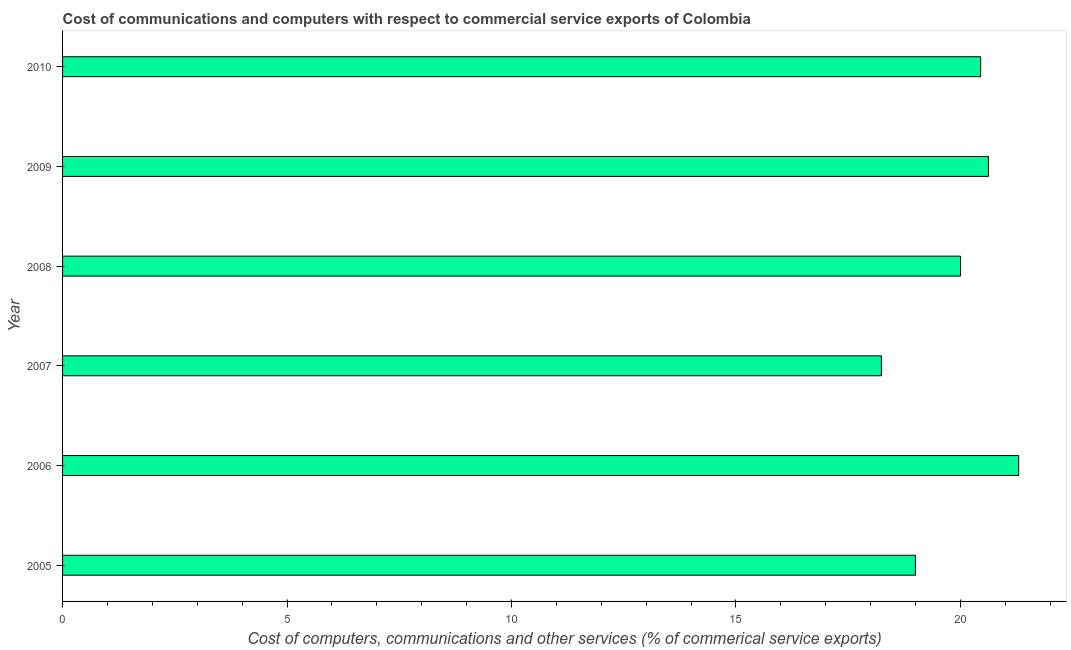What is the title of the graph?
Ensure brevity in your answer.  Cost of communications and computers with respect to commercial service exports of Colombia. What is the label or title of the X-axis?
Provide a succinct answer. Cost of computers, communications and other services (% of commerical service exports). What is the label or title of the Y-axis?
Your answer should be very brief. Year. What is the cost of communications in 2006?
Keep it short and to the point. 21.3. Across all years, what is the maximum cost of communications?
Offer a very short reply. 21.3. Across all years, what is the minimum  computer and other services?
Offer a very short reply. 18.24. In which year was the cost of communications maximum?
Your answer should be very brief. 2006. In which year was the  computer and other services minimum?
Your answer should be very brief. 2007. What is the sum of the  computer and other services?
Your response must be concise. 119.62. What is the difference between the cost of communications in 2005 and 2009?
Your answer should be very brief. -1.63. What is the average  computer and other services per year?
Ensure brevity in your answer.  19.94. What is the median cost of communications?
Ensure brevity in your answer.  20.23. What is the ratio of the cost of communications in 2007 to that in 2008?
Your answer should be very brief. 0.91. Is the  computer and other services in 2006 less than that in 2010?
Keep it short and to the point. No. What is the difference between the highest and the second highest cost of communications?
Keep it short and to the point. 0.67. Is the sum of the  computer and other services in 2006 and 2010 greater than the maximum  computer and other services across all years?
Make the answer very short. Yes. What is the difference between the highest and the lowest  computer and other services?
Make the answer very short. 3.06. In how many years, is the  computer and other services greater than the average  computer and other services taken over all years?
Provide a short and direct response. 4. Are all the bars in the graph horizontal?
Your answer should be compact. Yes. What is the difference between two consecutive major ticks on the X-axis?
Ensure brevity in your answer.  5. What is the Cost of computers, communications and other services (% of commerical service exports) of 2005?
Offer a very short reply. 19. What is the Cost of computers, communications and other services (% of commerical service exports) in 2006?
Provide a short and direct response. 21.3. What is the Cost of computers, communications and other services (% of commerical service exports) of 2007?
Offer a terse response. 18.24. What is the Cost of computers, communications and other services (% of commerical service exports) of 2008?
Provide a short and direct response. 20. What is the Cost of computers, communications and other services (% of commerical service exports) in 2009?
Keep it short and to the point. 20.63. What is the Cost of computers, communications and other services (% of commerical service exports) of 2010?
Keep it short and to the point. 20.45. What is the difference between the Cost of computers, communications and other services (% of commerical service exports) in 2005 and 2006?
Make the answer very short. -2.3. What is the difference between the Cost of computers, communications and other services (% of commerical service exports) in 2005 and 2007?
Make the answer very short. 0.76. What is the difference between the Cost of computers, communications and other services (% of commerical service exports) in 2005 and 2008?
Make the answer very short. -1.01. What is the difference between the Cost of computers, communications and other services (% of commerical service exports) in 2005 and 2009?
Give a very brief answer. -1.63. What is the difference between the Cost of computers, communications and other services (% of commerical service exports) in 2005 and 2010?
Give a very brief answer. -1.45. What is the difference between the Cost of computers, communications and other services (% of commerical service exports) in 2006 and 2007?
Offer a very short reply. 3.06. What is the difference between the Cost of computers, communications and other services (% of commerical service exports) in 2006 and 2008?
Ensure brevity in your answer.  1.29. What is the difference between the Cost of computers, communications and other services (% of commerical service exports) in 2006 and 2009?
Provide a succinct answer. 0.67. What is the difference between the Cost of computers, communications and other services (% of commerical service exports) in 2006 and 2010?
Your answer should be very brief. 0.85. What is the difference between the Cost of computers, communications and other services (% of commerical service exports) in 2007 and 2008?
Offer a terse response. -1.76. What is the difference between the Cost of computers, communications and other services (% of commerical service exports) in 2007 and 2009?
Your response must be concise. -2.38. What is the difference between the Cost of computers, communications and other services (% of commerical service exports) in 2007 and 2010?
Give a very brief answer. -2.21. What is the difference between the Cost of computers, communications and other services (% of commerical service exports) in 2008 and 2009?
Offer a terse response. -0.62. What is the difference between the Cost of computers, communications and other services (% of commerical service exports) in 2008 and 2010?
Provide a short and direct response. -0.45. What is the difference between the Cost of computers, communications and other services (% of commerical service exports) in 2009 and 2010?
Your answer should be compact. 0.17. What is the ratio of the Cost of computers, communications and other services (% of commerical service exports) in 2005 to that in 2006?
Your response must be concise. 0.89. What is the ratio of the Cost of computers, communications and other services (% of commerical service exports) in 2005 to that in 2007?
Offer a very short reply. 1.04. What is the ratio of the Cost of computers, communications and other services (% of commerical service exports) in 2005 to that in 2009?
Your answer should be very brief. 0.92. What is the ratio of the Cost of computers, communications and other services (% of commerical service exports) in 2005 to that in 2010?
Your answer should be very brief. 0.93. What is the ratio of the Cost of computers, communications and other services (% of commerical service exports) in 2006 to that in 2007?
Give a very brief answer. 1.17. What is the ratio of the Cost of computers, communications and other services (% of commerical service exports) in 2006 to that in 2008?
Make the answer very short. 1.06. What is the ratio of the Cost of computers, communications and other services (% of commerical service exports) in 2006 to that in 2009?
Offer a very short reply. 1.03. What is the ratio of the Cost of computers, communications and other services (% of commerical service exports) in 2006 to that in 2010?
Make the answer very short. 1.04. What is the ratio of the Cost of computers, communications and other services (% of commerical service exports) in 2007 to that in 2008?
Make the answer very short. 0.91. What is the ratio of the Cost of computers, communications and other services (% of commerical service exports) in 2007 to that in 2009?
Keep it short and to the point. 0.88. What is the ratio of the Cost of computers, communications and other services (% of commerical service exports) in 2007 to that in 2010?
Provide a short and direct response. 0.89. What is the ratio of the Cost of computers, communications and other services (% of commerical service exports) in 2008 to that in 2010?
Your answer should be compact. 0.98. 